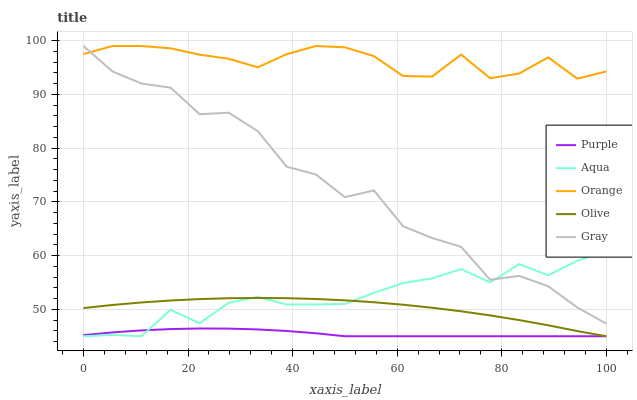Does Purple have the minimum area under the curve?
Answer yes or no. Yes. Does Orange have the maximum area under the curve?
Answer yes or no. Yes. Does Gray have the minimum area under the curve?
Answer yes or no. No. Does Gray have the maximum area under the curve?
Answer yes or no. No. Is Purple the smoothest?
Answer yes or no. Yes. Is Gray the roughest?
Answer yes or no. Yes. Is Orange the smoothest?
Answer yes or no. No. Is Orange the roughest?
Answer yes or no. No. Does Purple have the lowest value?
Answer yes or no. Yes. Does Gray have the lowest value?
Answer yes or no. No. Does Gray have the highest value?
Answer yes or no. Yes. Does Aqua have the highest value?
Answer yes or no. No. Is Purple less than Orange?
Answer yes or no. Yes. Is Orange greater than Aqua?
Answer yes or no. Yes. Does Olive intersect Purple?
Answer yes or no. Yes. Is Olive less than Purple?
Answer yes or no. No. Is Olive greater than Purple?
Answer yes or no. No. Does Purple intersect Orange?
Answer yes or no. No. 